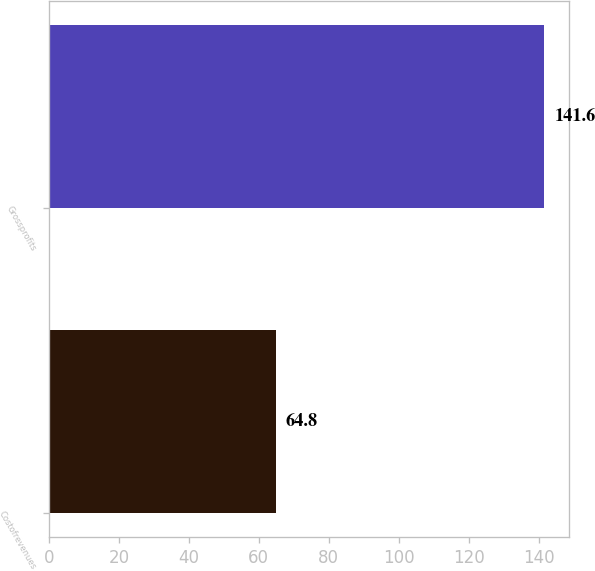Convert chart. <chart><loc_0><loc_0><loc_500><loc_500><bar_chart><fcel>Costofrevenues<fcel>Grossprofits<nl><fcel>64.8<fcel>141.6<nl></chart> 